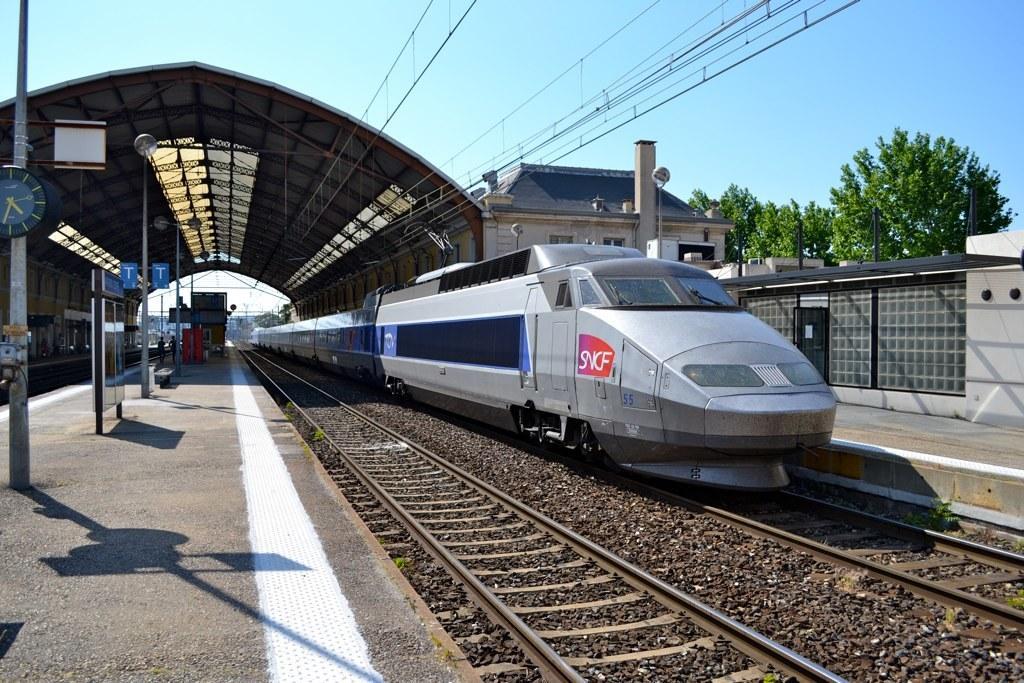Describe this image in one or two sentences. In this image in the center there is one train, and at the bottom there is a railway track. On the right side there are some buildings, trees, and some poles and wall. On the left side there are some poles and boards, and in the center there is ceiling and some iron poles. And also in the background there are some other objects, at the bottom there is a footpath. At the top of the image there is sky and some wires. 